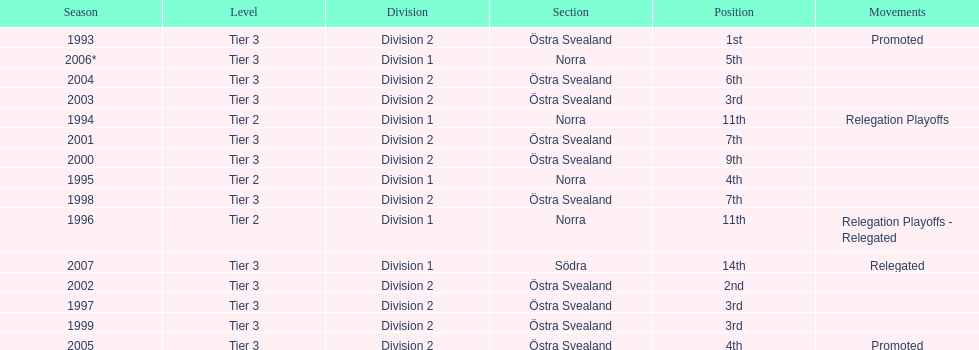How many times did they finish above 5th place in division 2 tier 3? 6. 